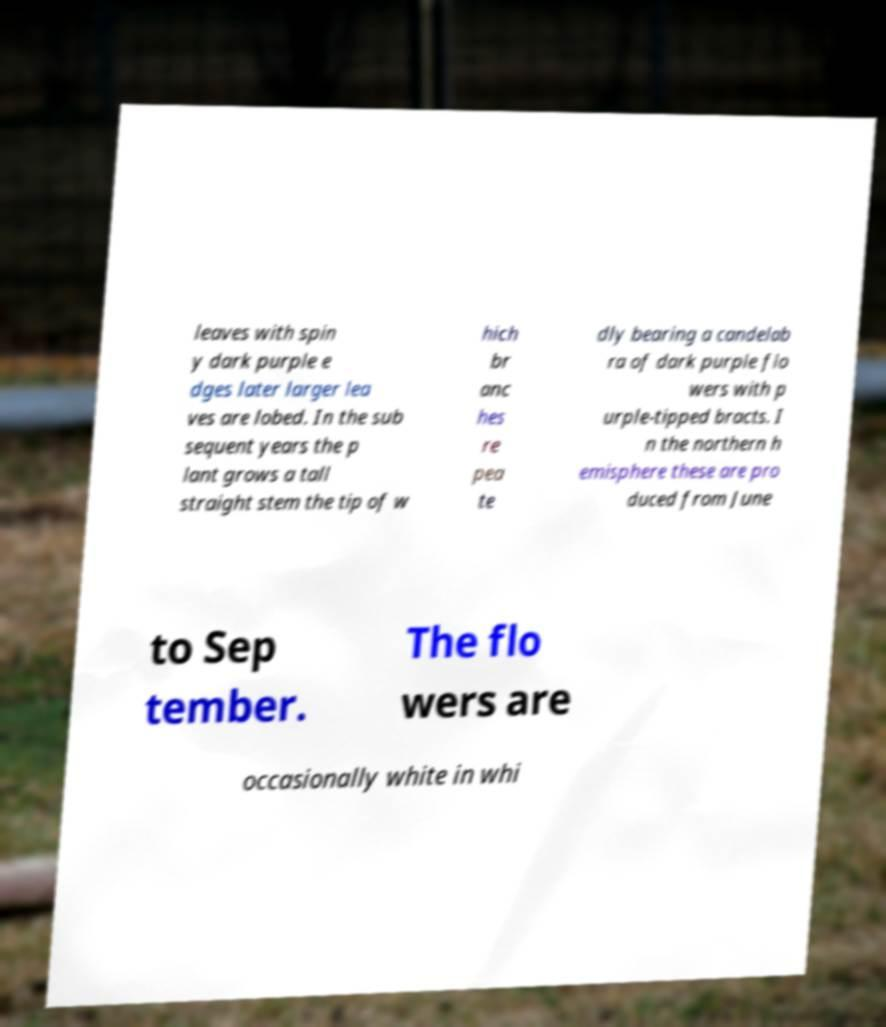Could you extract and type out the text from this image? leaves with spin y dark purple e dges later larger lea ves are lobed. In the sub sequent years the p lant grows a tall straight stem the tip of w hich br anc hes re pea te dly bearing a candelab ra of dark purple flo wers with p urple-tipped bracts. I n the northern h emisphere these are pro duced from June to Sep tember. The flo wers are occasionally white in whi 